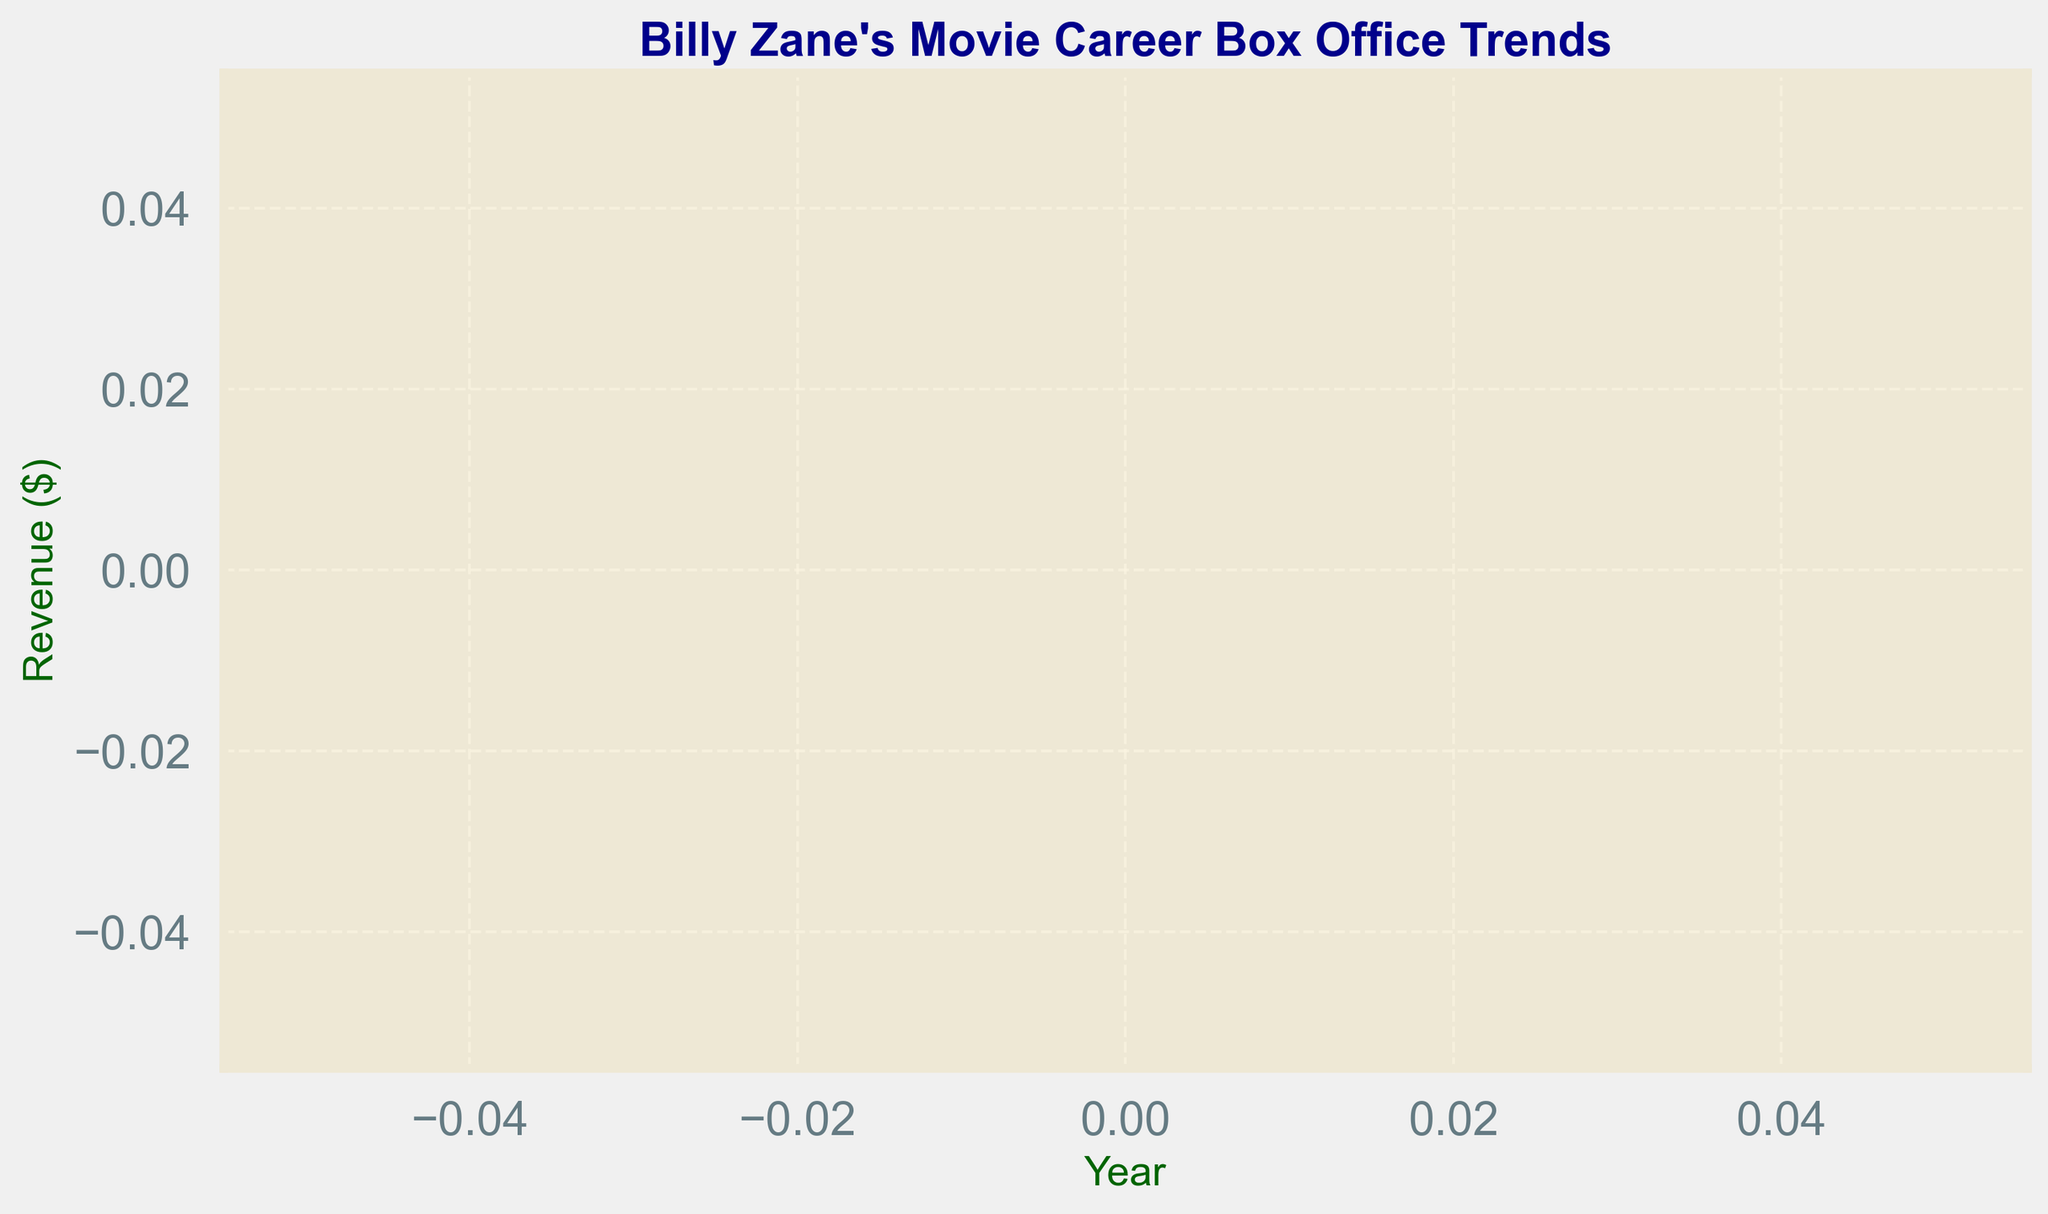What years are shown in the plot? The x-axis of the plot represents the years of Billy Zane's movie career, showing the data points for the years 2013 and 2021.
Answer: 2013, 2021 What is the box office revenue for the movie "Scorned"? The y-axis of the plot represents the box office revenue, and at the year 2013, the plot indicates the revenue for "Scorned".
Answer: $8 million Is there a movie listed for the year 2021? The plot marks an entry for the year 2021, but the y-axis does not show any value for box office revenue, indicating that it is not applicable (N/A).
Answer: Yes Which year has the higher box office revenue displayed on the plot? The plot only shows one year with box office revenue, which is 2013 for "Scorned". Since 2021 has no revenue listed, 2013 has the higher box office revenue.
Answer: 2013 What is the trend of Billy Zane's box office revenue from 2013 to 2021? From the plot, it can be seen that in 2013 there is box office revenue, whereas in 2021 there is no box office revenue recorded, suggesting a decreasing trend.
Answer: Decreasing How many data points are plotted in the figure? The plot shows the box office revenue for two different years, 2013 and 2021, hence indicating two data points.
Answer: 2 Compare the visual appearance of the data points in the plot. How are they marked? The data points in the plot are marked with circles. Each year with data has a different visual marker, with 2013 having a circle at a higher position on the vertical axis, and 2021 having no circle plotted for revenue.
Answer: Circles 